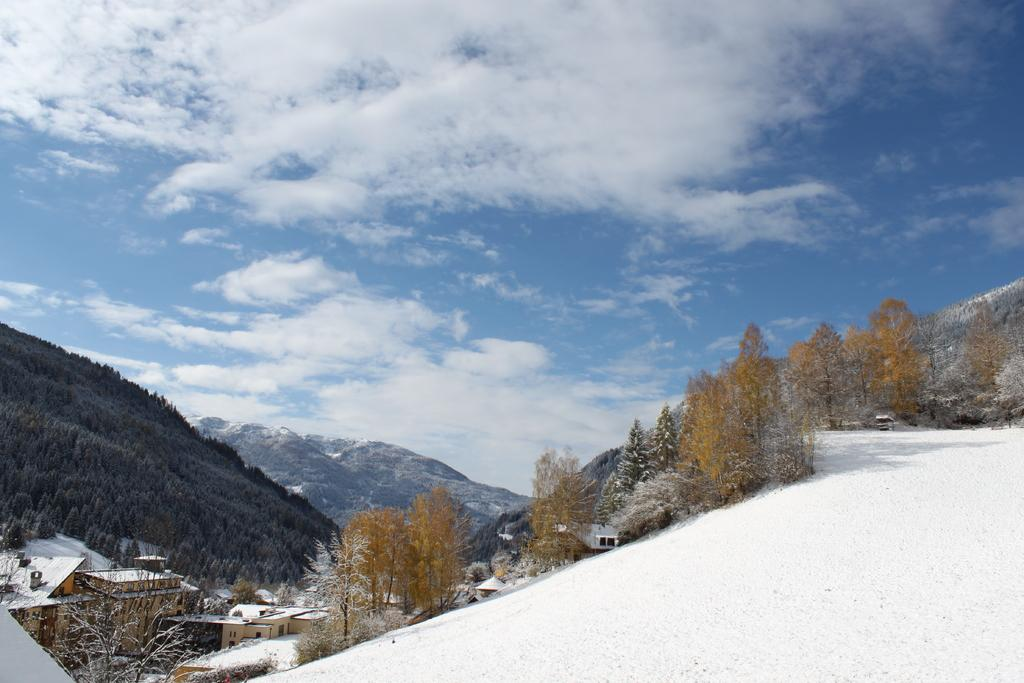What is located in the center of the image? There are trees in the center of the image. What type of structures can be seen in the image? There are buildings in the image. What can be seen in the distance in the image? There are mountains in the background of the image. What is the condition of the sky in the image? The sky is cloudy in the image. What type of paper can be seen blowing in the wind in the image? There is no paper present in the image; it features trees, buildings, mountains, and a cloudy sky. 